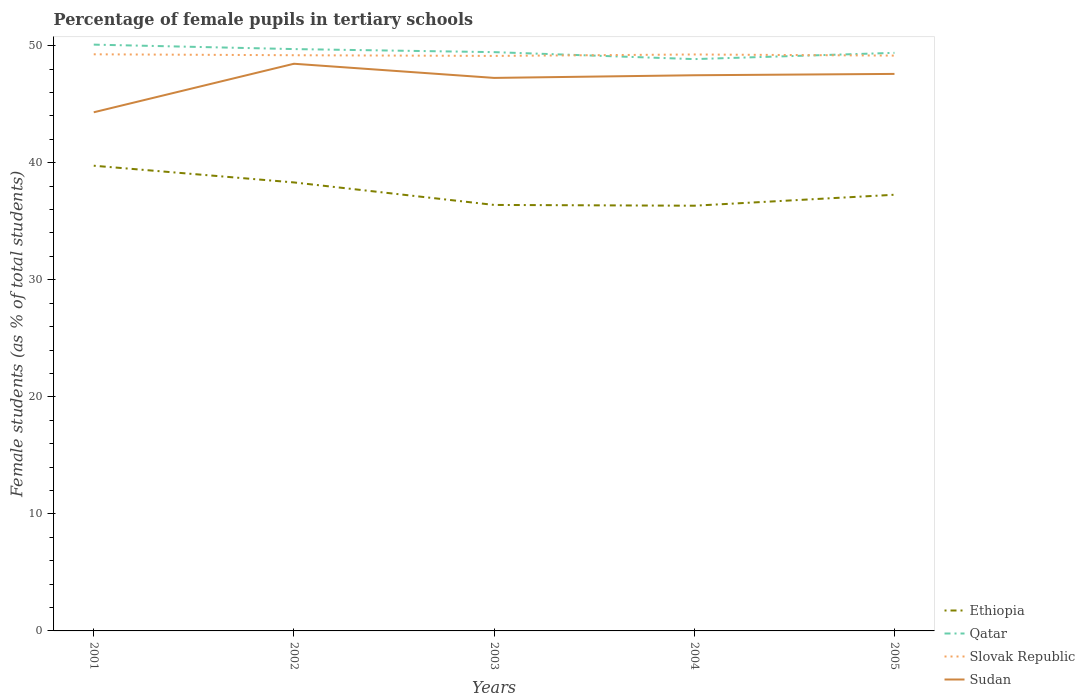How many different coloured lines are there?
Offer a very short reply. 4. Does the line corresponding to Qatar intersect with the line corresponding to Sudan?
Give a very brief answer. No. Is the number of lines equal to the number of legend labels?
Your response must be concise. Yes. Across all years, what is the maximum percentage of female pupils in tertiary schools in Sudan?
Keep it short and to the point. 44.31. What is the total percentage of female pupils in tertiary schools in Ethiopia in the graph?
Keep it short and to the point. 1.92. What is the difference between the highest and the second highest percentage of female pupils in tertiary schools in Qatar?
Make the answer very short. 1.24. What is the difference between the highest and the lowest percentage of female pupils in tertiary schools in Slovak Republic?
Give a very brief answer. 2. Is the percentage of female pupils in tertiary schools in Qatar strictly greater than the percentage of female pupils in tertiary schools in Slovak Republic over the years?
Offer a very short reply. No. How many lines are there?
Provide a short and direct response. 4. Where does the legend appear in the graph?
Ensure brevity in your answer.  Bottom right. How are the legend labels stacked?
Keep it short and to the point. Vertical. What is the title of the graph?
Keep it short and to the point. Percentage of female pupils in tertiary schools. Does "European Union" appear as one of the legend labels in the graph?
Offer a terse response. No. What is the label or title of the Y-axis?
Keep it short and to the point. Female students (as % of total students). What is the Female students (as % of total students) of Ethiopia in 2001?
Provide a short and direct response. 39.75. What is the Female students (as % of total students) in Qatar in 2001?
Keep it short and to the point. 50.09. What is the Female students (as % of total students) of Slovak Republic in 2001?
Your response must be concise. 49.27. What is the Female students (as % of total students) of Sudan in 2001?
Your answer should be compact. 44.31. What is the Female students (as % of total students) of Ethiopia in 2002?
Keep it short and to the point. 38.32. What is the Female students (as % of total students) in Qatar in 2002?
Provide a short and direct response. 49.71. What is the Female students (as % of total students) in Slovak Republic in 2002?
Provide a succinct answer. 49.19. What is the Female students (as % of total students) of Sudan in 2002?
Provide a short and direct response. 48.46. What is the Female students (as % of total students) of Ethiopia in 2003?
Your response must be concise. 36.4. What is the Female students (as % of total students) of Qatar in 2003?
Offer a very short reply. 49.45. What is the Female students (as % of total students) in Slovak Republic in 2003?
Offer a terse response. 49.13. What is the Female students (as % of total students) of Sudan in 2003?
Your answer should be very brief. 47.25. What is the Female students (as % of total students) in Ethiopia in 2004?
Ensure brevity in your answer.  36.33. What is the Female students (as % of total students) of Qatar in 2004?
Offer a very short reply. 48.86. What is the Female students (as % of total students) of Slovak Republic in 2004?
Keep it short and to the point. 49.25. What is the Female students (as % of total students) of Sudan in 2004?
Your response must be concise. 47.48. What is the Female students (as % of total students) of Ethiopia in 2005?
Give a very brief answer. 37.27. What is the Female students (as % of total students) in Qatar in 2005?
Your answer should be very brief. 49.39. What is the Female students (as % of total students) in Slovak Republic in 2005?
Make the answer very short. 49.15. What is the Female students (as % of total students) of Sudan in 2005?
Your answer should be very brief. 47.59. Across all years, what is the maximum Female students (as % of total students) in Ethiopia?
Your answer should be compact. 39.75. Across all years, what is the maximum Female students (as % of total students) in Qatar?
Keep it short and to the point. 50.09. Across all years, what is the maximum Female students (as % of total students) of Slovak Republic?
Provide a short and direct response. 49.27. Across all years, what is the maximum Female students (as % of total students) of Sudan?
Your response must be concise. 48.46. Across all years, what is the minimum Female students (as % of total students) of Ethiopia?
Offer a very short reply. 36.33. Across all years, what is the minimum Female students (as % of total students) of Qatar?
Keep it short and to the point. 48.86. Across all years, what is the minimum Female students (as % of total students) in Slovak Republic?
Keep it short and to the point. 49.13. Across all years, what is the minimum Female students (as % of total students) of Sudan?
Your answer should be very brief. 44.31. What is the total Female students (as % of total students) of Ethiopia in the graph?
Your answer should be very brief. 188.06. What is the total Female students (as % of total students) in Qatar in the graph?
Your answer should be compact. 247.5. What is the total Female students (as % of total students) of Slovak Republic in the graph?
Ensure brevity in your answer.  245.99. What is the total Female students (as % of total students) in Sudan in the graph?
Your response must be concise. 235.09. What is the difference between the Female students (as % of total students) of Ethiopia in 2001 and that in 2002?
Provide a succinct answer. 1.43. What is the difference between the Female students (as % of total students) of Qatar in 2001 and that in 2002?
Offer a terse response. 0.38. What is the difference between the Female students (as % of total students) of Slovak Republic in 2001 and that in 2002?
Your answer should be compact. 0.08. What is the difference between the Female students (as % of total students) in Sudan in 2001 and that in 2002?
Your response must be concise. -4.15. What is the difference between the Female students (as % of total students) in Ethiopia in 2001 and that in 2003?
Your answer should be very brief. 3.35. What is the difference between the Female students (as % of total students) in Qatar in 2001 and that in 2003?
Provide a succinct answer. 0.64. What is the difference between the Female students (as % of total students) in Slovak Republic in 2001 and that in 2003?
Your answer should be very brief. 0.14. What is the difference between the Female students (as % of total students) of Sudan in 2001 and that in 2003?
Provide a short and direct response. -2.94. What is the difference between the Female students (as % of total students) in Ethiopia in 2001 and that in 2004?
Give a very brief answer. 3.42. What is the difference between the Female students (as % of total students) in Qatar in 2001 and that in 2004?
Provide a short and direct response. 1.24. What is the difference between the Female students (as % of total students) of Slovak Republic in 2001 and that in 2004?
Ensure brevity in your answer.  0.01. What is the difference between the Female students (as % of total students) of Sudan in 2001 and that in 2004?
Offer a very short reply. -3.16. What is the difference between the Female students (as % of total students) of Ethiopia in 2001 and that in 2005?
Provide a short and direct response. 2.48. What is the difference between the Female students (as % of total students) in Qatar in 2001 and that in 2005?
Your response must be concise. 0.7. What is the difference between the Female students (as % of total students) of Slovak Republic in 2001 and that in 2005?
Your answer should be compact. 0.11. What is the difference between the Female students (as % of total students) of Sudan in 2001 and that in 2005?
Keep it short and to the point. -3.28. What is the difference between the Female students (as % of total students) in Ethiopia in 2002 and that in 2003?
Keep it short and to the point. 1.92. What is the difference between the Female students (as % of total students) in Qatar in 2002 and that in 2003?
Keep it short and to the point. 0.26. What is the difference between the Female students (as % of total students) of Slovak Republic in 2002 and that in 2003?
Give a very brief answer. 0.06. What is the difference between the Female students (as % of total students) in Sudan in 2002 and that in 2003?
Offer a very short reply. 1.21. What is the difference between the Female students (as % of total students) in Ethiopia in 2002 and that in 2004?
Ensure brevity in your answer.  1.99. What is the difference between the Female students (as % of total students) of Qatar in 2002 and that in 2004?
Provide a succinct answer. 0.86. What is the difference between the Female students (as % of total students) in Slovak Republic in 2002 and that in 2004?
Give a very brief answer. -0.06. What is the difference between the Female students (as % of total students) in Sudan in 2002 and that in 2004?
Give a very brief answer. 0.98. What is the difference between the Female students (as % of total students) of Ethiopia in 2002 and that in 2005?
Offer a terse response. 1.05. What is the difference between the Female students (as % of total students) in Qatar in 2002 and that in 2005?
Your answer should be compact. 0.32. What is the difference between the Female students (as % of total students) of Slovak Republic in 2002 and that in 2005?
Your answer should be very brief. 0.03. What is the difference between the Female students (as % of total students) of Sudan in 2002 and that in 2005?
Make the answer very short. 0.87. What is the difference between the Female students (as % of total students) in Ethiopia in 2003 and that in 2004?
Your answer should be compact. 0.07. What is the difference between the Female students (as % of total students) in Qatar in 2003 and that in 2004?
Keep it short and to the point. 0.6. What is the difference between the Female students (as % of total students) of Slovak Republic in 2003 and that in 2004?
Offer a terse response. -0.12. What is the difference between the Female students (as % of total students) of Sudan in 2003 and that in 2004?
Ensure brevity in your answer.  -0.23. What is the difference between the Female students (as % of total students) in Ethiopia in 2003 and that in 2005?
Provide a short and direct response. -0.87. What is the difference between the Female students (as % of total students) in Qatar in 2003 and that in 2005?
Offer a very short reply. 0.06. What is the difference between the Female students (as % of total students) in Slovak Republic in 2003 and that in 2005?
Offer a very short reply. -0.03. What is the difference between the Female students (as % of total students) in Sudan in 2003 and that in 2005?
Your answer should be compact. -0.34. What is the difference between the Female students (as % of total students) in Ethiopia in 2004 and that in 2005?
Keep it short and to the point. -0.94. What is the difference between the Female students (as % of total students) of Qatar in 2004 and that in 2005?
Provide a short and direct response. -0.54. What is the difference between the Female students (as % of total students) of Slovak Republic in 2004 and that in 2005?
Give a very brief answer. 0.1. What is the difference between the Female students (as % of total students) of Sudan in 2004 and that in 2005?
Make the answer very short. -0.12. What is the difference between the Female students (as % of total students) in Ethiopia in 2001 and the Female students (as % of total students) in Qatar in 2002?
Provide a succinct answer. -9.97. What is the difference between the Female students (as % of total students) of Ethiopia in 2001 and the Female students (as % of total students) of Slovak Republic in 2002?
Keep it short and to the point. -9.44. What is the difference between the Female students (as % of total students) of Ethiopia in 2001 and the Female students (as % of total students) of Sudan in 2002?
Your answer should be compact. -8.71. What is the difference between the Female students (as % of total students) of Qatar in 2001 and the Female students (as % of total students) of Slovak Republic in 2002?
Make the answer very short. 0.91. What is the difference between the Female students (as % of total students) of Qatar in 2001 and the Female students (as % of total students) of Sudan in 2002?
Offer a terse response. 1.63. What is the difference between the Female students (as % of total students) in Slovak Republic in 2001 and the Female students (as % of total students) in Sudan in 2002?
Provide a short and direct response. 0.81. What is the difference between the Female students (as % of total students) in Ethiopia in 2001 and the Female students (as % of total students) in Qatar in 2003?
Make the answer very short. -9.7. What is the difference between the Female students (as % of total students) in Ethiopia in 2001 and the Female students (as % of total students) in Slovak Republic in 2003?
Ensure brevity in your answer.  -9.38. What is the difference between the Female students (as % of total students) of Ethiopia in 2001 and the Female students (as % of total students) of Sudan in 2003?
Keep it short and to the point. -7.5. What is the difference between the Female students (as % of total students) in Qatar in 2001 and the Female students (as % of total students) in Slovak Republic in 2003?
Your answer should be very brief. 0.96. What is the difference between the Female students (as % of total students) of Qatar in 2001 and the Female students (as % of total students) of Sudan in 2003?
Give a very brief answer. 2.84. What is the difference between the Female students (as % of total students) in Slovak Republic in 2001 and the Female students (as % of total students) in Sudan in 2003?
Give a very brief answer. 2.02. What is the difference between the Female students (as % of total students) in Ethiopia in 2001 and the Female students (as % of total students) in Qatar in 2004?
Offer a terse response. -9.11. What is the difference between the Female students (as % of total students) in Ethiopia in 2001 and the Female students (as % of total students) in Slovak Republic in 2004?
Provide a succinct answer. -9.5. What is the difference between the Female students (as % of total students) of Ethiopia in 2001 and the Female students (as % of total students) of Sudan in 2004?
Your answer should be very brief. -7.73. What is the difference between the Female students (as % of total students) of Qatar in 2001 and the Female students (as % of total students) of Slovak Republic in 2004?
Give a very brief answer. 0.84. What is the difference between the Female students (as % of total students) of Qatar in 2001 and the Female students (as % of total students) of Sudan in 2004?
Provide a succinct answer. 2.62. What is the difference between the Female students (as % of total students) in Slovak Republic in 2001 and the Female students (as % of total students) in Sudan in 2004?
Your answer should be very brief. 1.79. What is the difference between the Female students (as % of total students) in Ethiopia in 2001 and the Female students (as % of total students) in Qatar in 2005?
Keep it short and to the point. -9.64. What is the difference between the Female students (as % of total students) in Ethiopia in 2001 and the Female students (as % of total students) in Slovak Republic in 2005?
Your answer should be compact. -9.41. What is the difference between the Female students (as % of total students) of Ethiopia in 2001 and the Female students (as % of total students) of Sudan in 2005?
Offer a terse response. -7.84. What is the difference between the Female students (as % of total students) of Qatar in 2001 and the Female students (as % of total students) of Slovak Republic in 2005?
Offer a very short reply. 0.94. What is the difference between the Female students (as % of total students) of Qatar in 2001 and the Female students (as % of total students) of Sudan in 2005?
Give a very brief answer. 2.5. What is the difference between the Female students (as % of total students) of Slovak Republic in 2001 and the Female students (as % of total students) of Sudan in 2005?
Make the answer very short. 1.67. What is the difference between the Female students (as % of total students) in Ethiopia in 2002 and the Female students (as % of total students) in Qatar in 2003?
Offer a very short reply. -11.13. What is the difference between the Female students (as % of total students) of Ethiopia in 2002 and the Female students (as % of total students) of Slovak Republic in 2003?
Ensure brevity in your answer.  -10.81. What is the difference between the Female students (as % of total students) of Ethiopia in 2002 and the Female students (as % of total students) of Sudan in 2003?
Offer a terse response. -8.93. What is the difference between the Female students (as % of total students) in Qatar in 2002 and the Female students (as % of total students) in Slovak Republic in 2003?
Your response must be concise. 0.58. What is the difference between the Female students (as % of total students) in Qatar in 2002 and the Female students (as % of total students) in Sudan in 2003?
Provide a succinct answer. 2.46. What is the difference between the Female students (as % of total students) of Slovak Republic in 2002 and the Female students (as % of total students) of Sudan in 2003?
Offer a very short reply. 1.94. What is the difference between the Female students (as % of total students) of Ethiopia in 2002 and the Female students (as % of total students) of Qatar in 2004?
Provide a short and direct response. -10.54. What is the difference between the Female students (as % of total students) of Ethiopia in 2002 and the Female students (as % of total students) of Slovak Republic in 2004?
Give a very brief answer. -10.93. What is the difference between the Female students (as % of total students) in Ethiopia in 2002 and the Female students (as % of total students) in Sudan in 2004?
Offer a terse response. -9.16. What is the difference between the Female students (as % of total students) in Qatar in 2002 and the Female students (as % of total students) in Slovak Republic in 2004?
Ensure brevity in your answer.  0.46. What is the difference between the Female students (as % of total students) of Qatar in 2002 and the Female students (as % of total students) of Sudan in 2004?
Give a very brief answer. 2.24. What is the difference between the Female students (as % of total students) of Slovak Republic in 2002 and the Female students (as % of total students) of Sudan in 2004?
Keep it short and to the point. 1.71. What is the difference between the Female students (as % of total students) of Ethiopia in 2002 and the Female students (as % of total students) of Qatar in 2005?
Offer a terse response. -11.07. What is the difference between the Female students (as % of total students) of Ethiopia in 2002 and the Female students (as % of total students) of Slovak Republic in 2005?
Keep it short and to the point. -10.83. What is the difference between the Female students (as % of total students) in Ethiopia in 2002 and the Female students (as % of total students) in Sudan in 2005?
Offer a very short reply. -9.27. What is the difference between the Female students (as % of total students) of Qatar in 2002 and the Female students (as % of total students) of Slovak Republic in 2005?
Offer a very short reply. 0.56. What is the difference between the Female students (as % of total students) in Qatar in 2002 and the Female students (as % of total students) in Sudan in 2005?
Ensure brevity in your answer.  2.12. What is the difference between the Female students (as % of total students) in Slovak Republic in 2002 and the Female students (as % of total students) in Sudan in 2005?
Make the answer very short. 1.6. What is the difference between the Female students (as % of total students) in Ethiopia in 2003 and the Female students (as % of total students) in Qatar in 2004?
Offer a very short reply. -12.46. What is the difference between the Female students (as % of total students) of Ethiopia in 2003 and the Female students (as % of total students) of Slovak Republic in 2004?
Give a very brief answer. -12.86. What is the difference between the Female students (as % of total students) of Ethiopia in 2003 and the Female students (as % of total students) of Sudan in 2004?
Ensure brevity in your answer.  -11.08. What is the difference between the Female students (as % of total students) of Qatar in 2003 and the Female students (as % of total students) of Slovak Republic in 2004?
Give a very brief answer. 0.2. What is the difference between the Female students (as % of total students) of Qatar in 2003 and the Female students (as % of total students) of Sudan in 2004?
Your answer should be compact. 1.97. What is the difference between the Female students (as % of total students) of Slovak Republic in 2003 and the Female students (as % of total students) of Sudan in 2004?
Your answer should be very brief. 1.65. What is the difference between the Female students (as % of total students) of Ethiopia in 2003 and the Female students (as % of total students) of Qatar in 2005?
Provide a short and direct response. -12.99. What is the difference between the Female students (as % of total students) of Ethiopia in 2003 and the Female students (as % of total students) of Slovak Republic in 2005?
Make the answer very short. -12.76. What is the difference between the Female students (as % of total students) of Ethiopia in 2003 and the Female students (as % of total students) of Sudan in 2005?
Provide a succinct answer. -11.2. What is the difference between the Female students (as % of total students) of Qatar in 2003 and the Female students (as % of total students) of Slovak Republic in 2005?
Make the answer very short. 0.3. What is the difference between the Female students (as % of total students) in Qatar in 2003 and the Female students (as % of total students) in Sudan in 2005?
Ensure brevity in your answer.  1.86. What is the difference between the Female students (as % of total students) of Slovak Republic in 2003 and the Female students (as % of total students) of Sudan in 2005?
Offer a very short reply. 1.54. What is the difference between the Female students (as % of total students) in Ethiopia in 2004 and the Female students (as % of total students) in Qatar in 2005?
Your answer should be compact. -13.06. What is the difference between the Female students (as % of total students) of Ethiopia in 2004 and the Female students (as % of total students) of Slovak Republic in 2005?
Provide a short and direct response. -12.82. What is the difference between the Female students (as % of total students) in Ethiopia in 2004 and the Female students (as % of total students) in Sudan in 2005?
Your response must be concise. -11.26. What is the difference between the Female students (as % of total students) in Qatar in 2004 and the Female students (as % of total students) in Slovak Republic in 2005?
Ensure brevity in your answer.  -0.3. What is the difference between the Female students (as % of total students) of Qatar in 2004 and the Female students (as % of total students) of Sudan in 2005?
Your response must be concise. 1.26. What is the difference between the Female students (as % of total students) in Slovak Republic in 2004 and the Female students (as % of total students) in Sudan in 2005?
Provide a succinct answer. 1.66. What is the average Female students (as % of total students) of Ethiopia per year?
Your answer should be very brief. 37.61. What is the average Female students (as % of total students) in Qatar per year?
Your answer should be compact. 49.5. What is the average Female students (as % of total students) of Slovak Republic per year?
Offer a terse response. 49.2. What is the average Female students (as % of total students) of Sudan per year?
Offer a terse response. 47.02. In the year 2001, what is the difference between the Female students (as % of total students) of Ethiopia and Female students (as % of total students) of Qatar?
Ensure brevity in your answer.  -10.35. In the year 2001, what is the difference between the Female students (as % of total students) in Ethiopia and Female students (as % of total students) in Slovak Republic?
Provide a succinct answer. -9.52. In the year 2001, what is the difference between the Female students (as % of total students) of Ethiopia and Female students (as % of total students) of Sudan?
Offer a very short reply. -4.57. In the year 2001, what is the difference between the Female students (as % of total students) in Qatar and Female students (as % of total students) in Slovak Republic?
Offer a terse response. 0.83. In the year 2001, what is the difference between the Female students (as % of total students) of Qatar and Female students (as % of total students) of Sudan?
Provide a succinct answer. 5.78. In the year 2001, what is the difference between the Female students (as % of total students) in Slovak Republic and Female students (as % of total students) in Sudan?
Give a very brief answer. 4.95. In the year 2002, what is the difference between the Female students (as % of total students) in Ethiopia and Female students (as % of total students) in Qatar?
Provide a succinct answer. -11.39. In the year 2002, what is the difference between the Female students (as % of total students) of Ethiopia and Female students (as % of total students) of Slovak Republic?
Provide a short and direct response. -10.87. In the year 2002, what is the difference between the Female students (as % of total students) in Ethiopia and Female students (as % of total students) in Sudan?
Give a very brief answer. -10.14. In the year 2002, what is the difference between the Female students (as % of total students) in Qatar and Female students (as % of total students) in Slovak Republic?
Your answer should be very brief. 0.53. In the year 2002, what is the difference between the Female students (as % of total students) of Qatar and Female students (as % of total students) of Sudan?
Keep it short and to the point. 1.25. In the year 2002, what is the difference between the Female students (as % of total students) of Slovak Republic and Female students (as % of total students) of Sudan?
Your answer should be compact. 0.73. In the year 2003, what is the difference between the Female students (as % of total students) of Ethiopia and Female students (as % of total students) of Qatar?
Give a very brief answer. -13.05. In the year 2003, what is the difference between the Female students (as % of total students) of Ethiopia and Female students (as % of total students) of Slovak Republic?
Offer a very short reply. -12.73. In the year 2003, what is the difference between the Female students (as % of total students) in Ethiopia and Female students (as % of total students) in Sudan?
Ensure brevity in your answer.  -10.85. In the year 2003, what is the difference between the Female students (as % of total students) of Qatar and Female students (as % of total students) of Slovak Republic?
Offer a terse response. 0.32. In the year 2003, what is the difference between the Female students (as % of total students) in Qatar and Female students (as % of total students) in Sudan?
Offer a very short reply. 2.2. In the year 2003, what is the difference between the Female students (as % of total students) of Slovak Republic and Female students (as % of total students) of Sudan?
Provide a short and direct response. 1.88. In the year 2004, what is the difference between the Female students (as % of total students) of Ethiopia and Female students (as % of total students) of Qatar?
Your answer should be very brief. -12.53. In the year 2004, what is the difference between the Female students (as % of total students) of Ethiopia and Female students (as % of total students) of Slovak Republic?
Ensure brevity in your answer.  -12.92. In the year 2004, what is the difference between the Female students (as % of total students) of Ethiopia and Female students (as % of total students) of Sudan?
Provide a short and direct response. -11.15. In the year 2004, what is the difference between the Female students (as % of total students) of Qatar and Female students (as % of total students) of Slovak Republic?
Provide a short and direct response. -0.4. In the year 2004, what is the difference between the Female students (as % of total students) in Qatar and Female students (as % of total students) in Sudan?
Keep it short and to the point. 1.38. In the year 2004, what is the difference between the Female students (as % of total students) in Slovak Republic and Female students (as % of total students) in Sudan?
Your answer should be compact. 1.78. In the year 2005, what is the difference between the Female students (as % of total students) in Ethiopia and Female students (as % of total students) in Qatar?
Ensure brevity in your answer.  -12.12. In the year 2005, what is the difference between the Female students (as % of total students) in Ethiopia and Female students (as % of total students) in Slovak Republic?
Offer a very short reply. -11.89. In the year 2005, what is the difference between the Female students (as % of total students) of Ethiopia and Female students (as % of total students) of Sudan?
Provide a succinct answer. -10.33. In the year 2005, what is the difference between the Female students (as % of total students) in Qatar and Female students (as % of total students) in Slovak Republic?
Your response must be concise. 0.24. In the year 2005, what is the difference between the Female students (as % of total students) of Qatar and Female students (as % of total students) of Sudan?
Your answer should be compact. 1.8. In the year 2005, what is the difference between the Female students (as % of total students) in Slovak Republic and Female students (as % of total students) in Sudan?
Your response must be concise. 1.56. What is the ratio of the Female students (as % of total students) of Ethiopia in 2001 to that in 2002?
Make the answer very short. 1.04. What is the ratio of the Female students (as % of total students) in Qatar in 2001 to that in 2002?
Your response must be concise. 1.01. What is the ratio of the Female students (as % of total students) of Sudan in 2001 to that in 2002?
Your response must be concise. 0.91. What is the ratio of the Female students (as % of total students) of Ethiopia in 2001 to that in 2003?
Your answer should be very brief. 1.09. What is the ratio of the Female students (as % of total students) of Qatar in 2001 to that in 2003?
Make the answer very short. 1.01. What is the ratio of the Female students (as % of total students) of Slovak Republic in 2001 to that in 2003?
Your answer should be very brief. 1. What is the ratio of the Female students (as % of total students) of Sudan in 2001 to that in 2003?
Ensure brevity in your answer.  0.94. What is the ratio of the Female students (as % of total students) in Ethiopia in 2001 to that in 2004?
Offer a very short reply. 1.09. What is the ratio of the Female students (as % of total students) in Qatar in 2001 to that in 2004?
Your response must be concise. 1.03. What is the ratio of the Female students (as % of total students) of Sudan in 2001 to that in 2004?
Your response must be concise. 0.93. What is the ratio of the Female students (as % of total students) of Ethiopia in 2001 to that in 2005?
Give a very brief answer. 1.07. What is the ratio of the Female students (as % of total students) of Qatar in 2001 to that in 2005?
Keep it short and to the point. 1.01. What is the ratio of the Female students (as % of total students) in Sudan in 2001 to that in 2005?
Provide a short and direct response. 0.93. What is the ratio of the Female students (as % of total students) in Ethiopia in 2002 to that in 2003?
Keep it short and to the point. 1.05. What is the ratio of the Female students (as % of total students) in Sudan in 2002 to that in 2003?
Offer a very short reply. 1.03. What is the ratio of the Female students (as % of total students) in Ethiopia in 2002 to that in 2004?
Offer a very short reply. 1.05. What is the ratio of the Female students (as % of total students) of Qatar in 2002 to that in 2004?
Give a very brief answer. 1.02. What is the ratio of the Female students (as % of total students) of Sudan in 2002 to that in 2004?
Your response must be concise. 1.02. What is the ratio of the Female students (as % of total students) of Ethiopia in 2002 to that in 2005?
Ensure brevity in your answer.  1.03. What is the ratio of the Female students (as % of total students) in Slovak Republic in 2002 to that in 2005?
Offer a very short reply. 1. What is the ratio of the Female students (as % of total students) of Sudan in 2002 to that in 2005?
Offer a very short reply. 1.02. What is the ratio of the Female students (as % of total students) of Qatar in 2003 to that in 2004?
Provide a short and direct response. 1.01. What is the ratio of the Female students (as % of total students) of Slovak Republic in 2003 to that in 2004?
Your response must be concise. 1. What is the ratio of the Female students (as % of total students) in Ethiopia in 2003 to that in 2005?
Provide a short and direct response. 0.98. What is the ratio of the Female students (as % of total students) of Slovak Republic in 2003 to that in 2005?
Provide a short and direct response. 1. What is the ratio of the Female students (as % of total students) in Sudan in 2003 to that in 2005?
Offer a terse response. 0.99. What is the ratio of the Female students (as % of total students) of Ethiopia in 2004 to that in 2005?
Your answer should be compact. 0.97. What is the ratio of the Female students (as % of total students) in Qatar in 2004 to that in 2005?
Offer a terse response. 0.99. What is the difference between the highest and the second highest Female students (as % of total students) in Ethiopia?
Your answer should be very brief. 1.43. What is the difference between the highest and the second highest Female students (as % of total students) in Qatar?
Keep it short and to the point. 0.38. What is the difference between the highest and the second highest Female students (as % of total students) of Slovak Republic?
Your response must be concise. 0.01. What is the difference between the highest and the second highest Female students (as % of total students) of Sudan?
Offer a very short reply. 0.87. What is the difference between the highest and the lowest Female students (as % of total students) in Ethiopia?
Provide a short and direct response. 3.42. What is the difference between the highest and the lowest Female students (as % of total students) in Qatar?
Make the answer very short. 1.24. What is the difference between the highest and the lowest Female students (as % of total students) of Slovak Republic?
Provide a succinct answer. 0.14. What is the difference between the highest and the lowest Female students (as % of total students) in Sudan?
Provide a succinct answer. 4.15. 